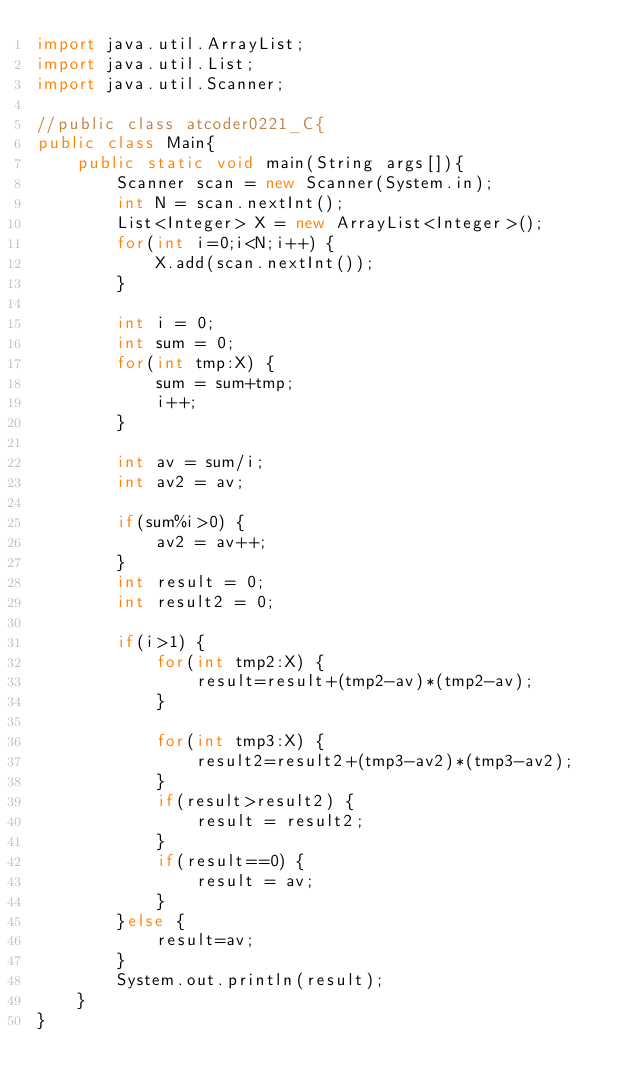Convert code to text. <code><loc_0><loc_0><loc_500><loc_500><_Java_>import java.util.ArrayList;
import java.util.List;
import java.util.Scanner;

//public class atcoder0221_C{
public class Main{
	public static void main(String args[]){
		Scanner scan = new Scanner(System.in);
		int N = scan.nextInt();
		List<Integer> X = new ArrayList<Integer>();
		for(int i=0;i<N;i++) {
			X.add(scan.nextInt());
		}

		int i = 0;
		int sum = 0;
		for(int tmp:X) {
			sum = sum+tmp;
			i++;
		}

		int av = sum/i;
		int av2 = av;

		if(sum%i>0) {
			av2 = av++;
		}
		int result = 0;
		int result2 = 0;

		if(i>1) {
			for(int tmp2:X) {
				result=result+(tmp2-av)*(tmp2-av);
			}

			for(int tmp3:X) {
				result2=result2+(tmp3-av2)*(tmp3-av2);
			}
			if(result>result2) {
				result = result2;
			}
			if(result==0) {
				result = av;
			}
		}else {
			result=av;
		}
		System.out.println(result);
	}
}

</code> 